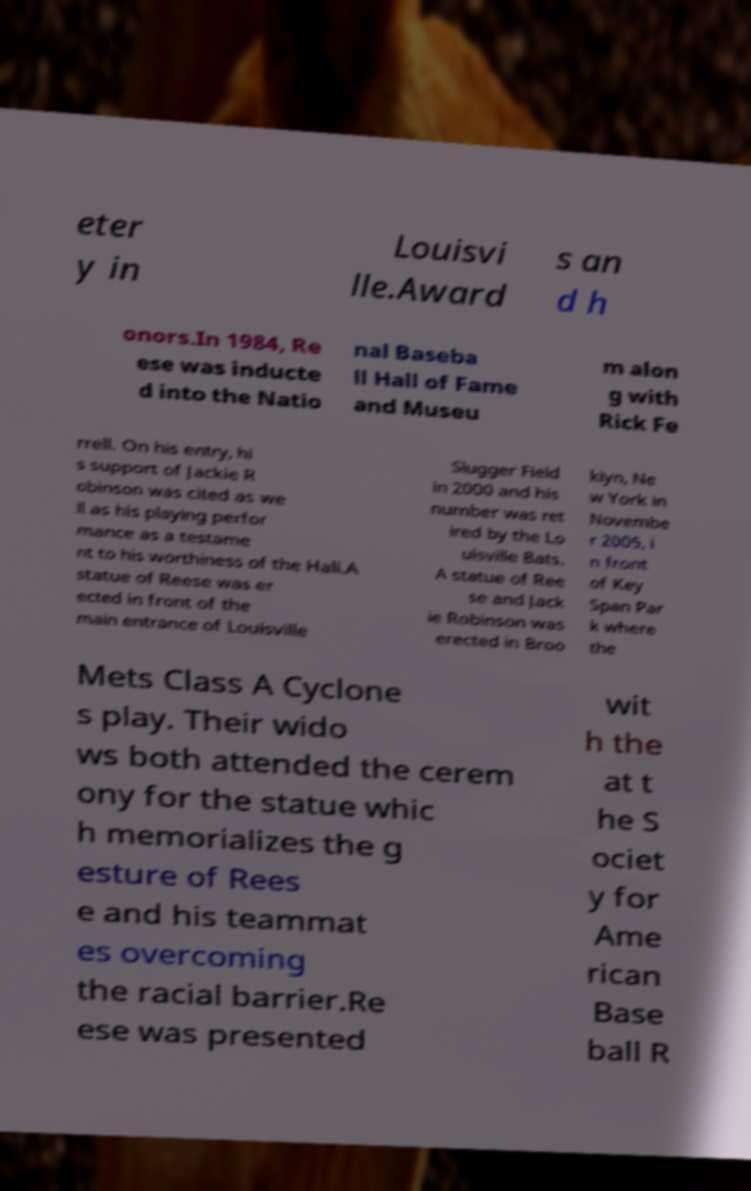I need the written content from this picture converted into text. Can you do that? eter y in Louisvi lle.Award s an d h onors.In 1984, Re ese was inducte d into the Natio nal Baseba ll Hall of Fame and Museu m alon g with Rick Fe rrell. On his entry, hi s support of Jackie R obinson was cited as we ll as his playing perfor mance as a testame nt to his worthiness of the Hall.A statue of Reese was er ected in front of the main entrance of Louisville Slugger Field in 2000 and his number was ret ired by the Lo uisville Bats. A statue of Ree se and Jack ie Robinson was erected in Broo klyn, Ne w York in Novembe r 2005, i n front of Key Span Par k where the Mets Class A Cyclone s play. Their wido ws both attended the cerem ony for the statue whic h memorializes the g esture of Rees e and his teammat es overcoming the racial barrier.Re ese was presented wit h the at t he S ociet y for Ame rican Base ball R 